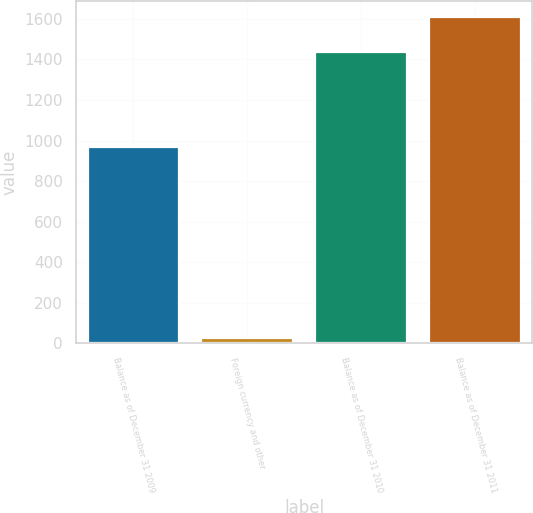<chart> <loc_0><loc_0><loc_500><loc_500><bar_chart><fcel>Balance as of December 31 2009<fcel>Foreign currency and other<fcel>Balance as of December 31 2010<fcel>Balance as of December 31 2011<nl><fcel>970<fcel>26<fcel>1437<fcel>1610<nl></chart> 